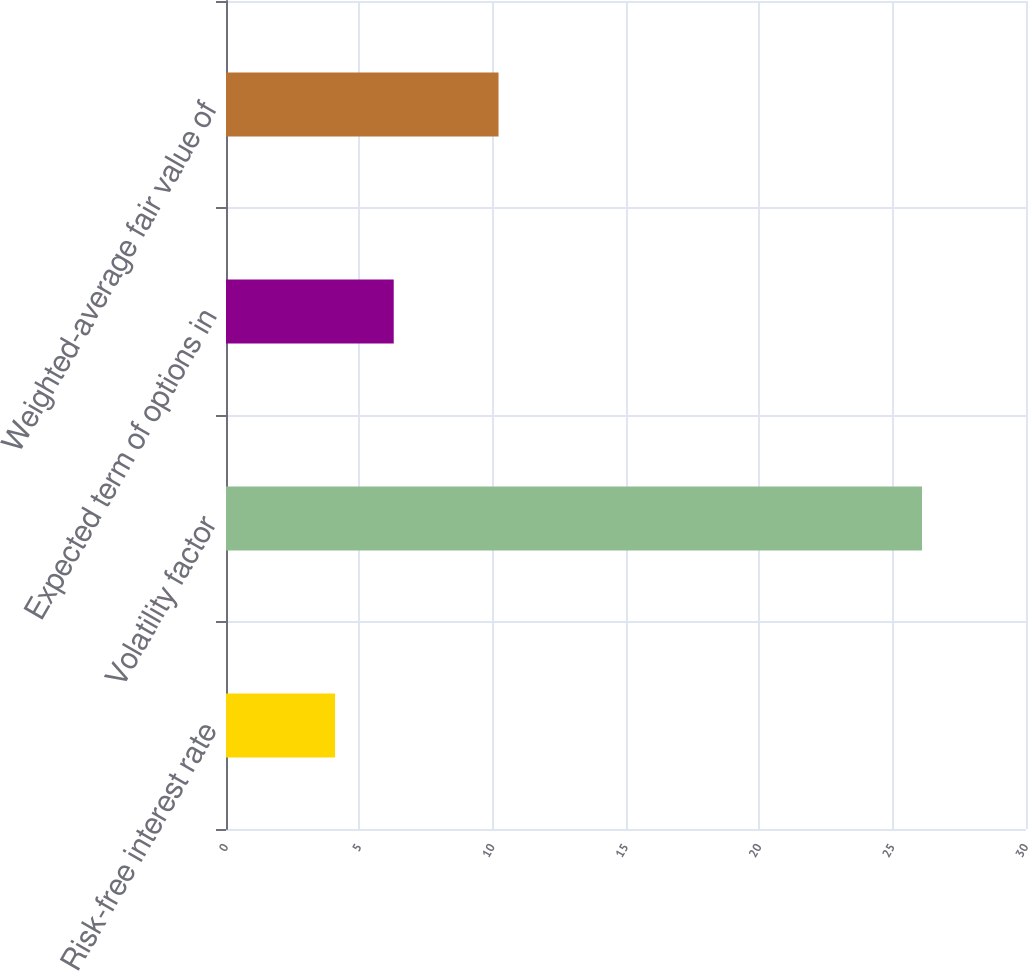Convert chart. <chart><loc_0><loc_0><loc_500><loc_500><bar_chart><fcel>Risk-free interest rate<fcel>Volatility factor<fcel>Expected term of options in<fcel>Weighted-average fair value of<nl><fcel>4.09<fcel>26.1<fcel>6.29<fcel>10.22<nl></chart> 